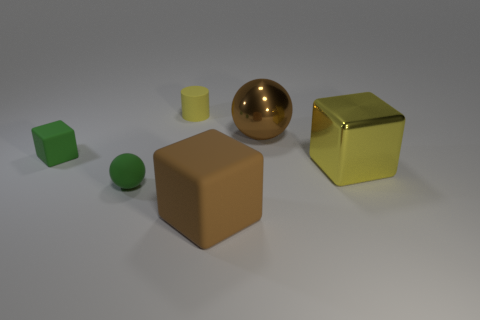There is a matte sphere left of the big brown object that is in front of the matte sphere; are there any big brown spheres behind it?
Make the answer very short. Yes. Do the cube left of the small yellow cylinder and the yellow cube have the same material?
Ensure brevity in your answer.  No. What color is the big matte object that is the same shape as the yellow metal object?
Offer a very short reply. Brown. Are there any other things that have the same shape as the yellow rubber thing?
Your answer should be compact. No. Are there an equal number of spheres in front of the large matte cube and large green shiny balls?
Offer a very short reply. Yes. Are there any green rubber things behind the yellow metallic cube?
Keep it short and to the point. Yes. What size is the block that is to the left of the matte thing behind the ball to the right of the yellow cylinder?
Provide a short and direct response. Small. There is a yellow thing that is to the left of the large brown sphere; is its shape the same as the brown object right of the large brown rubber thing?
Keep it short and to the point. No. There is a green thing that is the same shape as the yellow shiny thing; what is its size?
Provide a short and direct response. Small. How many other large balls are the same material as the big brown sphere?
Keep it short and to the point. 0. 